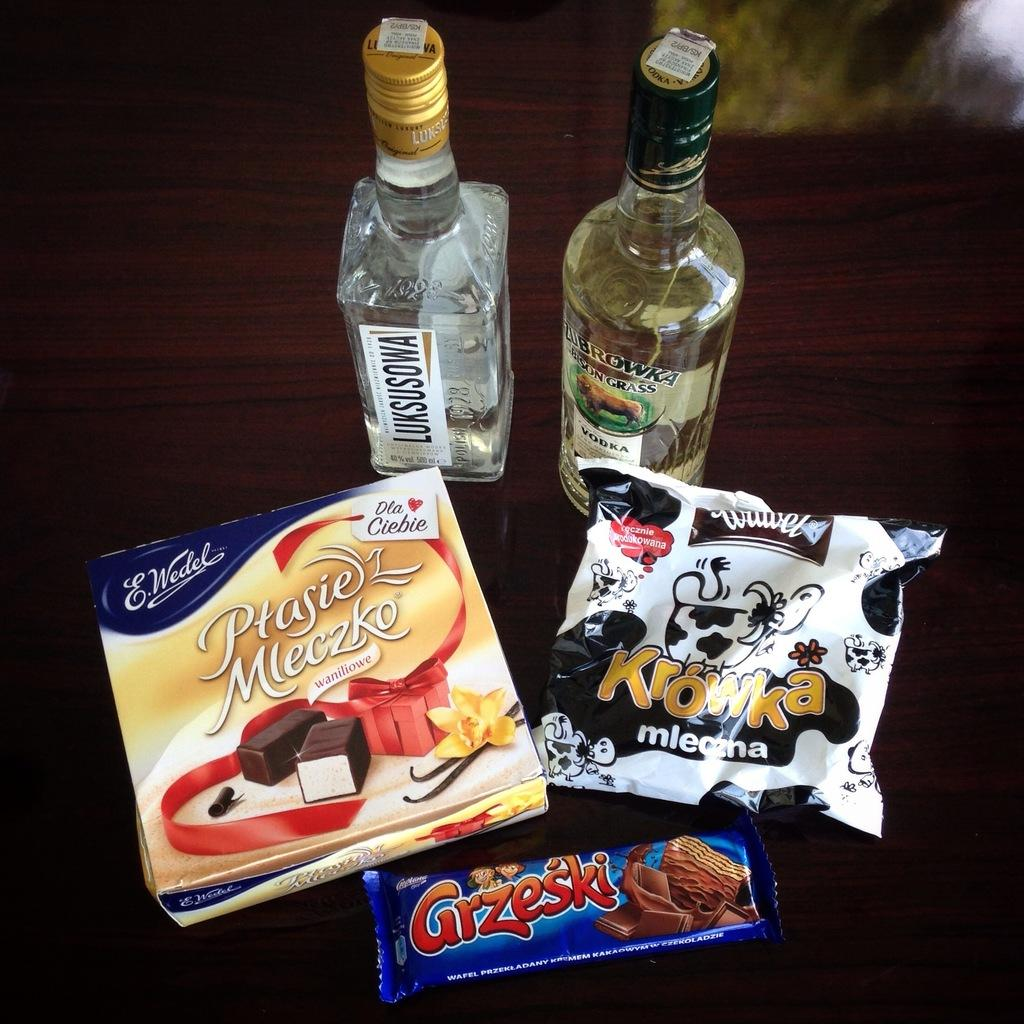What type of beverage is present in the image? There is a wine bottle in the image. What other items can be seen in the image besides the wine bottle? There are snacks and chocolate in the image. Are there any other objects on the table in the image? Yes, there are other objects on the table in the image. How many lizards can be seen crawling on the wine bottle in the image? There are no lizards present in the image. What is the price of the wine bottle in the image? The price of the wine bottle is not visible in the image. 